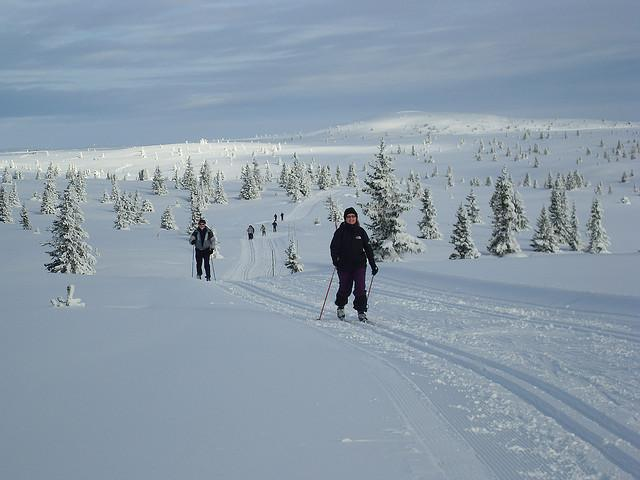What must the weather be like in this area? Please explain your reasoning. cold. There is snow everywhere, and the people have heavy jackets and gloves. 